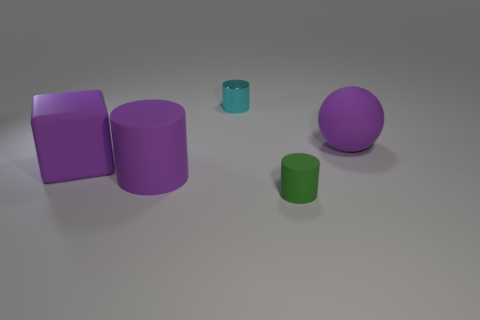Add 5 big gray rubber cubes. How many objects exist? 10 Subtract all cylinders. How many objects are left? 2 Subtract all cyan matte spheres. Subtract all cyan things. How many objects are left? 4 Add 3 large purple rubber things. How many large purple rubber things are left? 6 Add 4 cyan shiny objects. How many cyan shiny objects exist? 5 Subtract 0 green balls. How many objects are left? 5 